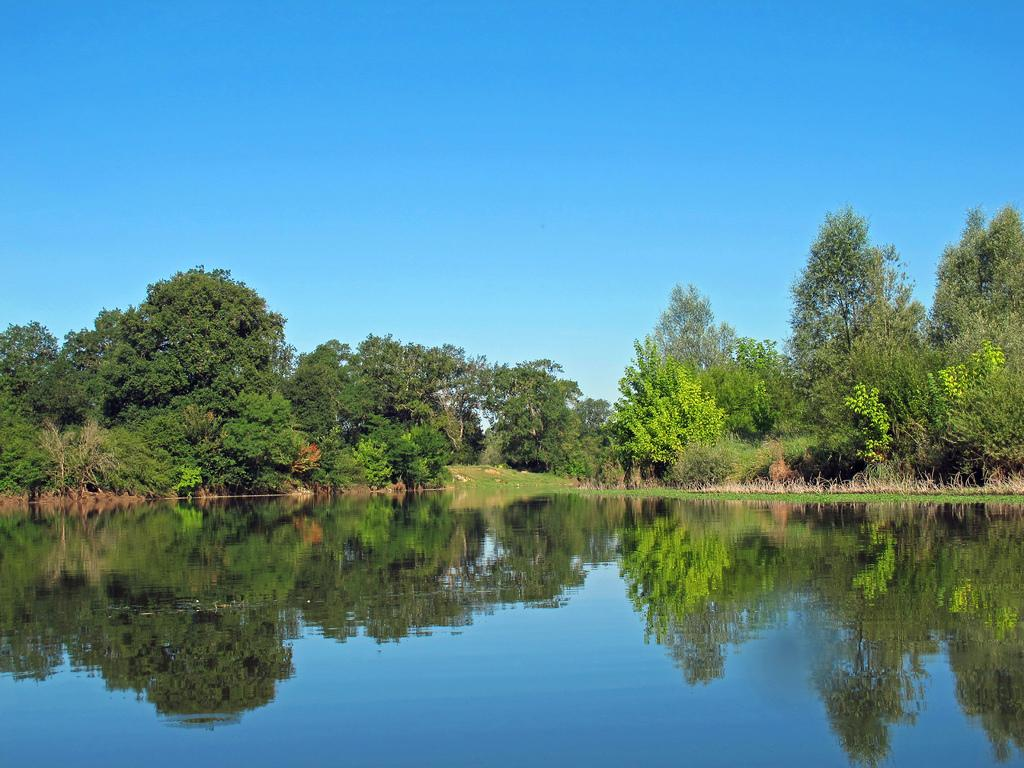What type of vegetation can be seen in the image? There are trees in the image. What is the effect of the trees on the water in the image? There are reflections of trees in the water in the image. What part of the natural environment is visible in the image? The sky is visible in the image. What type of suit can be seen hanging on the tree in the image? There is no suit present in the image; it features trees, reflections of trees in the water, and the sky. Can you see a bucket in the water in the image? There is no bucket present in the image; it features trees, reflections of trees in the water, and the sky. 